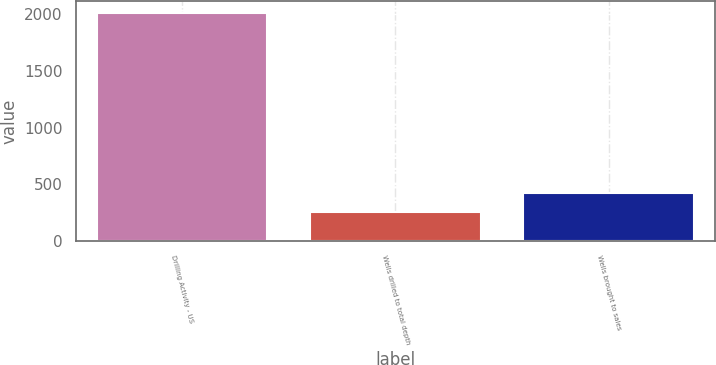<chart> <loc_0><loc_0><loc_500><loc_500><bar_chart><fcel>Drilling Activity - US<fcel>Wells drilled to total depth<fcel>Wells brought to sales<nl><fcel>2015<fcel>251<fcel>427.4<nl></chart> 